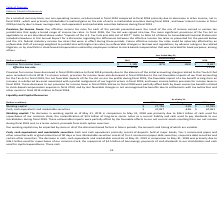Looking at Oracle Corporation's financial data, please calculate: How much was the average effective tax rate in 2018 and 2019? To answer this question, I need to perform calculations using the financial data. The calculation is: (9.7+71.1) / 2 , which equals 40.4 (percentage). This is based on the information: "Effective tax rate 9.7% 71.1% Effective tax rate 9.7% 71.1%..." The key data points involved are: 71.1, 9.7. Also, can you calculate: By how much less was the provision for income taxes in 2019 compared to 2018? Based on the calculation: 8,837 - 1,185 , the result is 7652 (in millions). This is based on the information: "Provision for income taxes $ 1,185 -87% -86% $ 8,837 Provision for income taxes $ 1,185 -87% -86% $ 8,837..." The key data points involved are: 1,185, 8,837. Also, can you calculate: How much was the total provision for income taxes across 2018 and 2019? Based on the calculation: 1,185 + 8,837 , the result is 10022 (in millions). This is based on the information: "Provision for income taxes $ 1,185 -87% -86% $ 8,837 Provision for income taxes $ 1,185 -87% -86% $ 8,837..." The key data points involved are: 1,185, 8,837. Also, Which section of the Tax Act is most significant to Oracle? Impacts of the U.S. Tax Cuts and Jobs Act of 2017. The document states: "ct as applicable to us are described above under “Impacts of the U.S. Tax Cuts and Jobs Act of 2017”. refer to Note 14 of Notes to Consolidated Financ..." Also, What are some reasons provided for possible adverse impact on effective income tax rates? Future effective income tax rates could be adversely affected by an unfavorable shift of earnings weighted to jurisdictions with higher tax rates, by unfavorable changes in tax laws and regulations, by adverse rulings in tax related litigation, or by shortfalls in stock-based compensation realized by employees relative to stock-based compensation that was recorded for book purposes, among others.. The document states: "ax rates that were in effect during these periods. Future effective income tax rates could be adversely affected by an unfavorable shift of earnings w..." Also, Why did the company's provision for income taxes not decrease as much in fiscal 2019 as expected? These decreases to our provision for income taxes in fiscal 2019 relative to fiscal 2018 were partially offset both by lower excess tax benefits related to stock-based compensation expense in fiscal 2019, and by less favorable changes in net unrecognized tax benefits due to settlements with tax authorities and other events in fiscal 2019 relative to fiscal 2018.. The document states: "before provision for income taxes in fiscal 2019. These decreases to our provision for income taxes in fiscal 2019 relative to fiscal 2018 were partia..." 